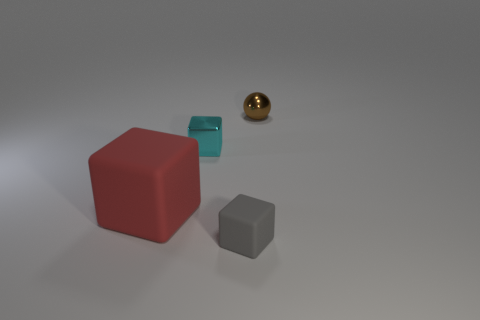Subtract all big matte cubes. How many cubes are left? 2 Add 1 purple blocks. How many objects exist? 5 Subtract all red blocks. How many blocks are left? 2 Subtract all blocks. How many objects are left? 1 Subtract 2 cubes. How many cubes are left? 1 Add 3 tiny brown shiny spheres. How many tiny brown shiny spheres are left? 4 Add 3 small purple rubber cylinders. How many small purple rubber cylinders exist? 3 Subtract 0 purple blocks. How many objects are left? 4 Subtract all gray cubes. Subtract all gray cylinders. How many cubes are left? 2 Subtract all large yellow shiny balls. Subtract all small cyan blocks. How many objects are left? 3 